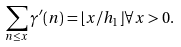Convert formula to latex. <formula><loc_0><loc_0><loc_500><loc_500>\sum _ { n \leq x } \gamma ^ { \prime } ( n ) = \lfloor x / h _ { 1 } \rfloor \forall x > 0 .</formula> 